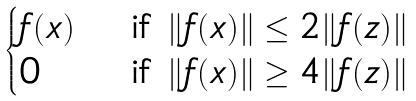<formula> <loc_0><loc_0><loc_500><loc_500>\begin{cases} f ( x ) & \text { if $\|f(x)\| \leq 2\|f(z)\|$} \\ 0 & \text { if $\|f(x)\| \geq 4\|f(z)\|$} \end{cases}</formula> 